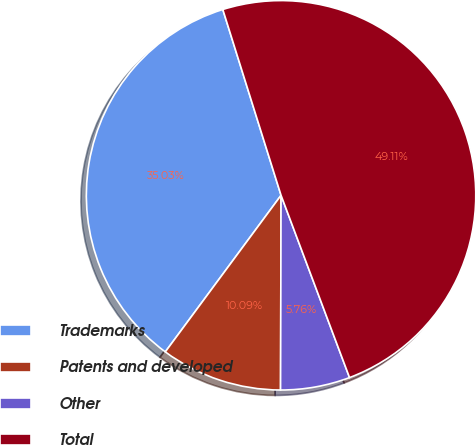<chart> <loc_0><loc_0><loc_500><loc_500><pie_chart><fcel>Trademarks<fcel>Patents and developed<fcel>Other<fcel>Total<nl><fcel>35.03%<fcel>10.09%<fcel>5.76%<fcel>49.11%<nl></chart> 